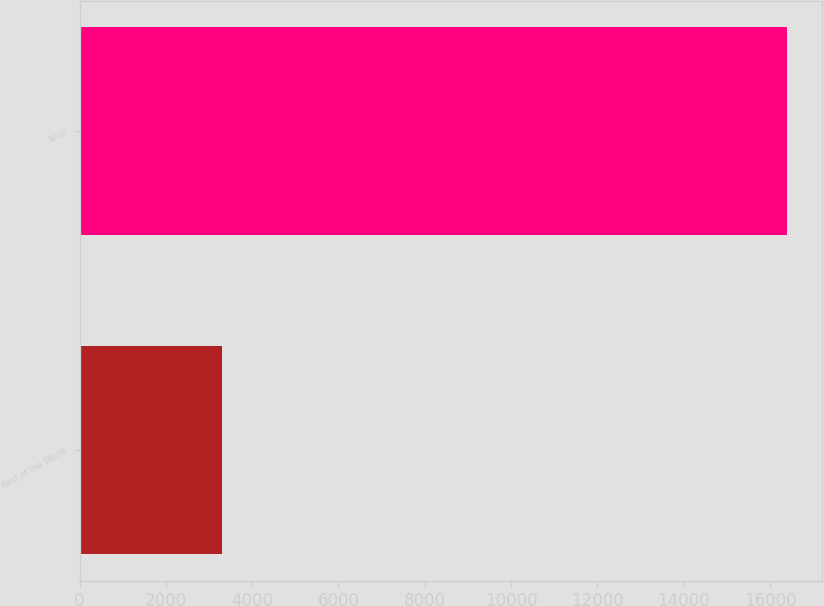Convert chart. <chart><loc_0><loc_0><loc_500><loc_500><bar_chart><fcel>Rest of the World<fcel>Total<nl><fcel>3295<fcel>16385<nl></chart> 